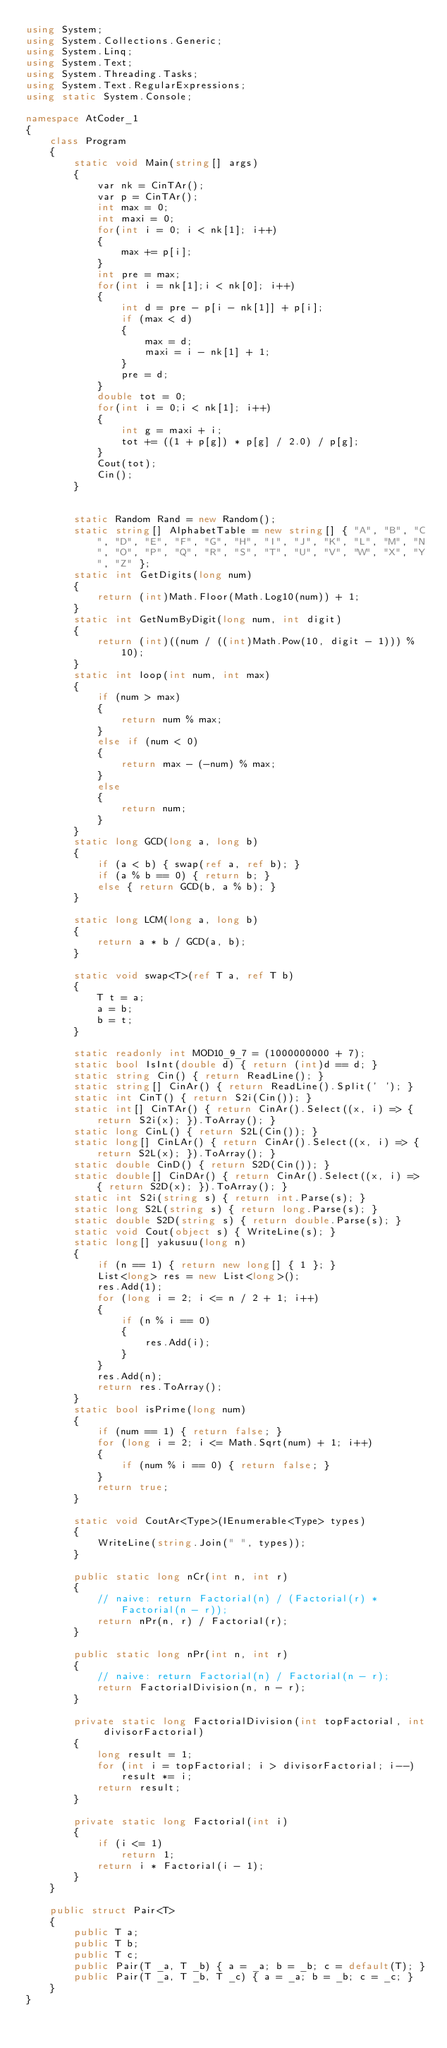Convert code to text. <code><loc_0><loc_0><loc_500><loc_500><_C#_>using System;
using System.Collections.Generic;
using System.Linq;
using System.Text;
using System.Threading.Tasks;
using System.Text.RegularExpressions;
using static System.Console;

namespace AtCoder_1
{
    class Program
    {
        static void Main(string[] args)
        {
            var nk = CinTAr();
            var p = CinTAr();
            int max = 0;
            int maxi = 0;
            for(int i = 0; i < nk[1]; i++)
            {
                max += p[i];
            }
            int pre = max;
            for(int i = nk[1];i < nk[0]; i++)
            {
                int d = pre - p[i - nk[1]] + p[i];
                if (max < d)
                {
                    max = d;
                    maxi = i - nk[1] + 1;
                }
                pre = d;
            }
            double tot = 0;
            for(int i = 0;i < nk[1]; i++)
            {
                int g = maxi + i;
                tot += ((1 + p[g]) * p[g] / 2.0) / p[g];
            }
            Cout(tot);
            Cin();
        }


        static Random Rand = new Random();
        static string[] AlphabetTable = new string[] { "A", "B", "C", "D", "E", "F", "G", "H", "I", "J", "K", "L", "M", "N", "O", "P", "Q", "R", "S", "T", "U", "V", "W", "X", "Y", "Z" };
        static int GetDigits(long num)
        {
            return (int)Math.Floor(Math.Log10(num)) + 1;
        }
        static int GetNumByDigit(long num, int digit)
        {
            return (int)((num / ((int)Math.Pow(10, digit - 1))) % 10);
        }
        static int loop(int num, int max)
        {
            if (num > max)
            {
                return num % max;
            }
            else if (num < 0)
            {
                return max - (-num) % max;
            }
            else
            {
                return num;
            }
        }
        static long GCD(long a, long b)
        {
            if (a < b) { swap(ref a, ref b); }
            if (a % b == 0) { return b; }
            else { return GCD(b, a % b); }
        }

        static long LCM(long a, long b)
        {
            return a * b / GCD(a, b);
        }

        static void swap<T>(ref T a, ref T b)
        {
            T t = a;
            a = b;
            b = t;
        }

        static readonly int MOD10_9_7 = (1000000000 + 7);
        static bool IsInt(double d) { return (int)d == d; }
        static string Cin() { return ReadLine(); }
        static string[] CinAr() { return ReadLine().Split(' '); }
        static int CinT() { return S2i(Cin()); }
        static int[] CinTAr() { return CinAr().Select((x, i) => { return S2i(x); }).ToArray(); }
        static long CinL() { return S2L(Cin()); }
        static long[] CinLAr() { return CinAr().Select((x, i) => { return S2L(x); }).ToArray(); }
        static double CinD() { return S2D(Cin()); }
        static double[] CinDAr() { return CinAr().Select((x, i) => { return S2D(x); }).ToArray(); }
        static int S2i(string s) { return int.Parse(s); }
        static long S2L(string s) { return long.Parse(s); }
        static double S2D(string s) { return double.Parse(s); }
        static void Cout(object s) { WriteLine(s); }
        static long[] yakusuu(long n)
        {
            if (n == 1) { return new long[] { 1 }; }
            List<long> res = new List<long>();
            res.Add(1);
            for (long i = 2; i <= n / 2 + 1; i++)
            {
                if (n % i == 0)
                {
                    res.Add(i);
                }
            }
            res.Add(n);
            return res.ToArray();
        }
        static bool isPrime(long num)
        {
            if (num == 1) { return false; }
            for (long i = 2; i <= Math.Sqrt(num) + 1; i++)
            {
                if (num % i == 0) { return false; }
            }
            return true;
        }

        static void CoutAr<Type>(IEnumerable<Type> types)
        {
            WriteLine(string.Join(" ", types));
        }

        public static long nCr(int n, int r)
        {
            // naive: return Factorial(n) / (Factorial(r) * Factorial(n - r));
            return nPr(n, r) / Factorial(r);
        }

        public static long nPr(int n, int r)
        {
            // naive: return Factorial(n) / Factorial(n - r);
            return FactorialDivision(n, n - r);
        }

        private static long FactorialDivision(int topFactorial, int divisorFactorial)
        {
            long result = 1;
            for (int i = topFactorial; i > divisorFactorial; i--)
                result *= i;
            return result;
        }

        private static long Factorial(int i)
        {
            if (i <= 1)
                return 1;
            return i * Factorial(i - 1);
        }
    }

    public struct Pair<T>
    {
        public T a;
        public T b;
        public T c;
        public Pair(T _a, T _b) { a = _a; b = _b; c = default(T); }
        public Pair(T _a, T _b, T _c) { a = _a; b = _b; c = _c; }
    }
}
</code> 